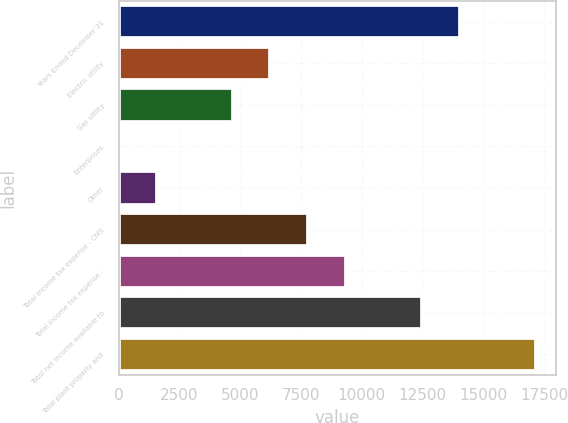<chart> <loc_0><loc_0><loc_500><loc_500><bar_chart><fcel>Years Ended December 31<fcel>Electric utility<fcel>Gas utility<fcel>Enterprises<fcel>Other<fcel>Total income tax expense - CMS<fcel>Total income tax expense -<fcel>Total net income available to<fcel>Total plant property and<nl><fcel>14032.9<fcel>6237.4<fcel>4678.3<fcel>1<fcel>1560.1<fcel>7796.5<fcel>9355.6<fcel>12473.8<fcel>17151.1<nl></chart> 